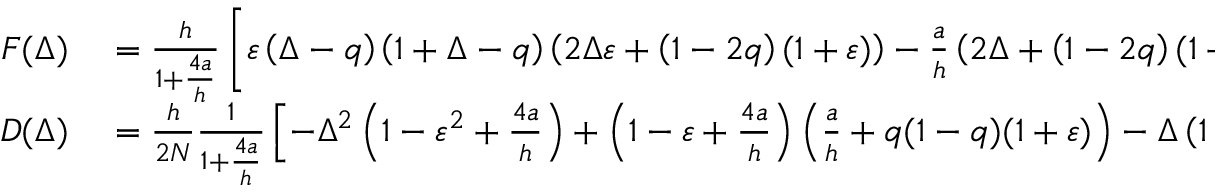<formula> <loc_0><loc_0><loc_500><loc_500>\begin{array} { r l } { F ( \Delta ) } & = \frac { h } { 1 + \frac { 4 a } { h } } \left [ \varepsilon \left ( \Delta - q \right ) \left ( 1 + \Delta - q \right ) \left ( 2 \Delta \varepsilon + \left ( 1 - 2 q \right ) ( 1 + \varepsilon ) \right ) - \frac { a } { h } \left ( 2 \Delta + \left ( 1 - 2 q \right ) ( 1 + \varepsilon ) \right ) - 4 \left ( \frac { a } { h } \right ) ^ { 2 } \left ( 2 \Delta + 1 - 2 q \right ) \right ] , } \\ { D ( \Delta ) } & = \frac { h } { 2 N } \frac { 1 } { 1 + \frac { 4 a } { h } } \left [ - \Delta ^ { 2 } \left ( 1 - \varepsilon ^ { 2 } + \frac { 4 a } { h } \right ) + \left ( 1 - \varepsilon + \frac { 4 a } { h } \right ) \left ( \frac { a } { h } + q ( 1 - q ) ( 1 + \varepsilon ) \right ) - \Delta \left ( 1 - 2 q \right ) \left ( 1 - \varepsilon ^ { 2 } + ( 2 + \varepsilon ) \frac { 2 a } { h } \right ) \right ] , } \end{array}</formula> 